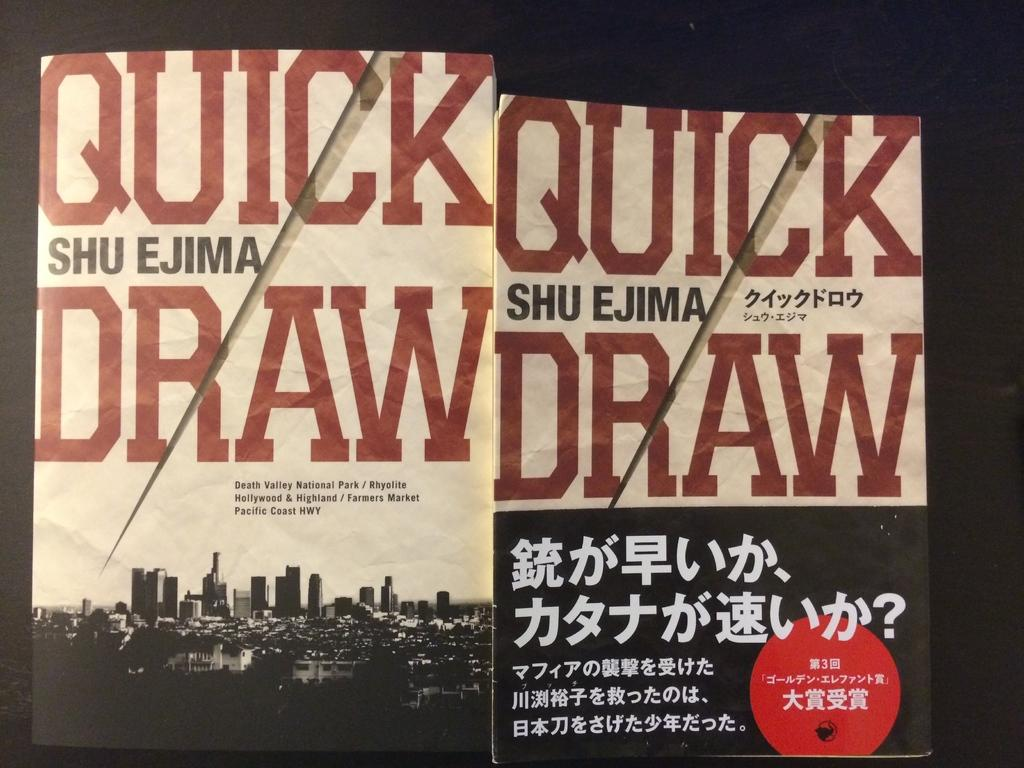<image>
Write a terse but informative summary of the picture. Two copies of the novel Quick Draw by Shu Ejima 